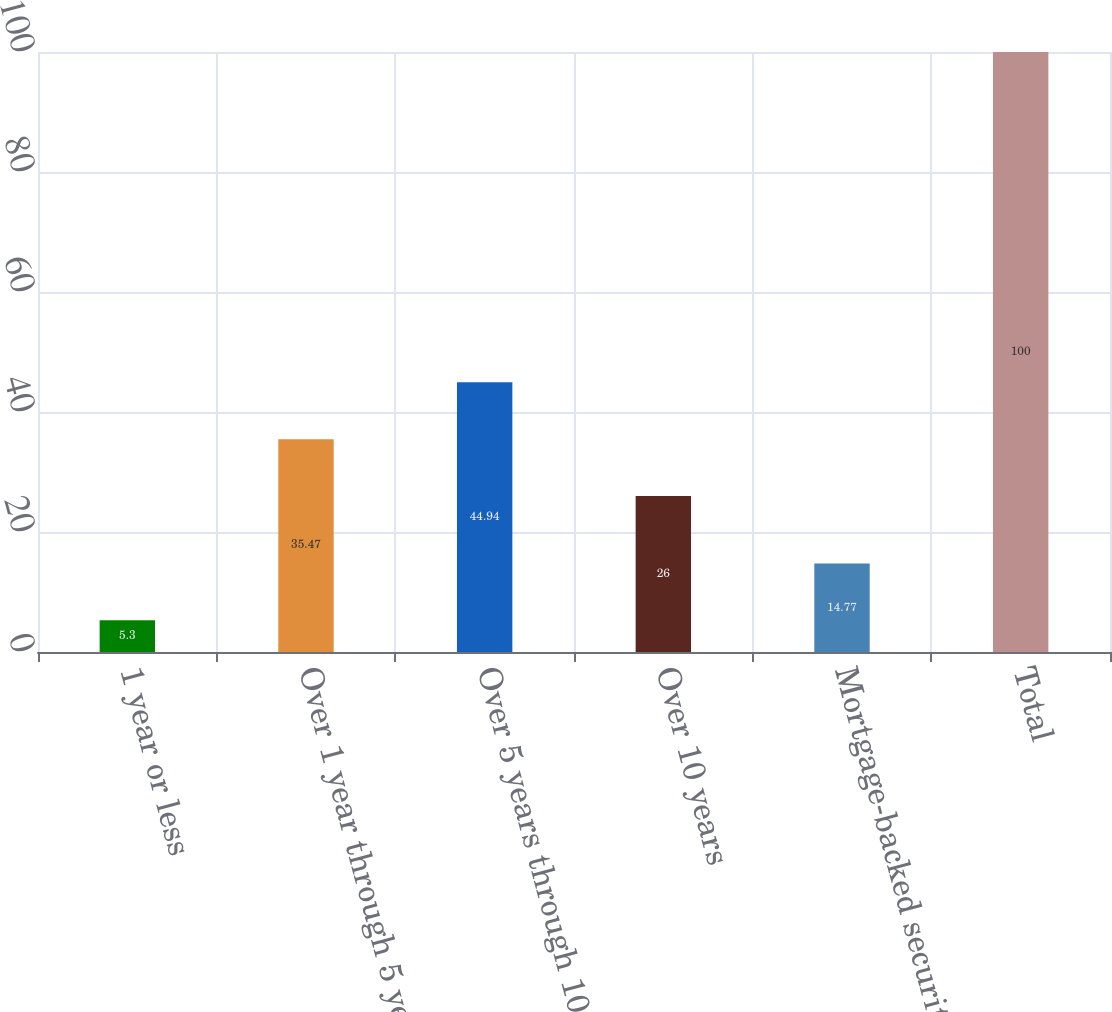<chart> <loc_0><loc_0><loc_500><loc_500><bar_chart><fcel>1 year or less<fcel>Over 1 year through 5 years<fcel>Over 5 years through 10 years<fcel>Over 10 years<fcel>Mortgage-backed securities<fcel>Total<nl><fcel>5.3<fcel>35.47<fcel>44.94<fcel>26<fcel>14.77<fcel>100<nl></chart> 